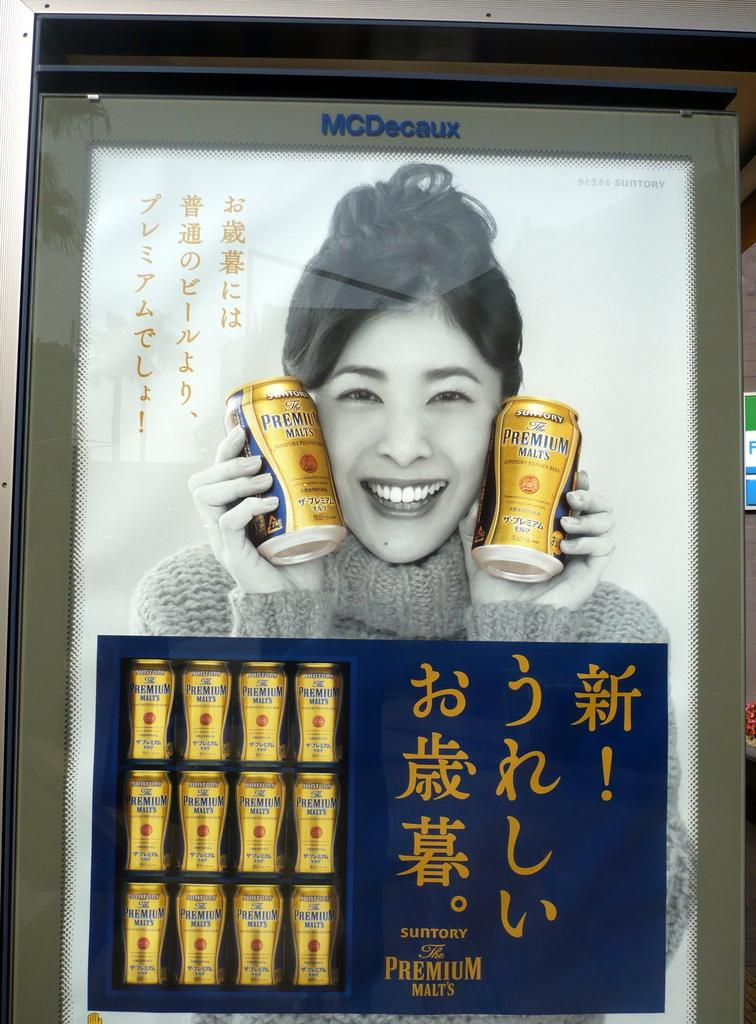What is the main subject of the hoarding in the image? The fact does not provide information about the content of the hoarding. Who is present in the image besides the hoarding? There is a woman in the image. What is the woman doing with her hands? The woman is holding twins in her hands. What is the woman's facial expression? The woman is smiling. What type of caption can be seen at the bottom of the hoarding in the image? There is no caption visible at the bottom of the hoarding in the image. Can you tell me how many twigs the woman is holding in her hands? The woman is holding twins, not twigs, in her hands. 